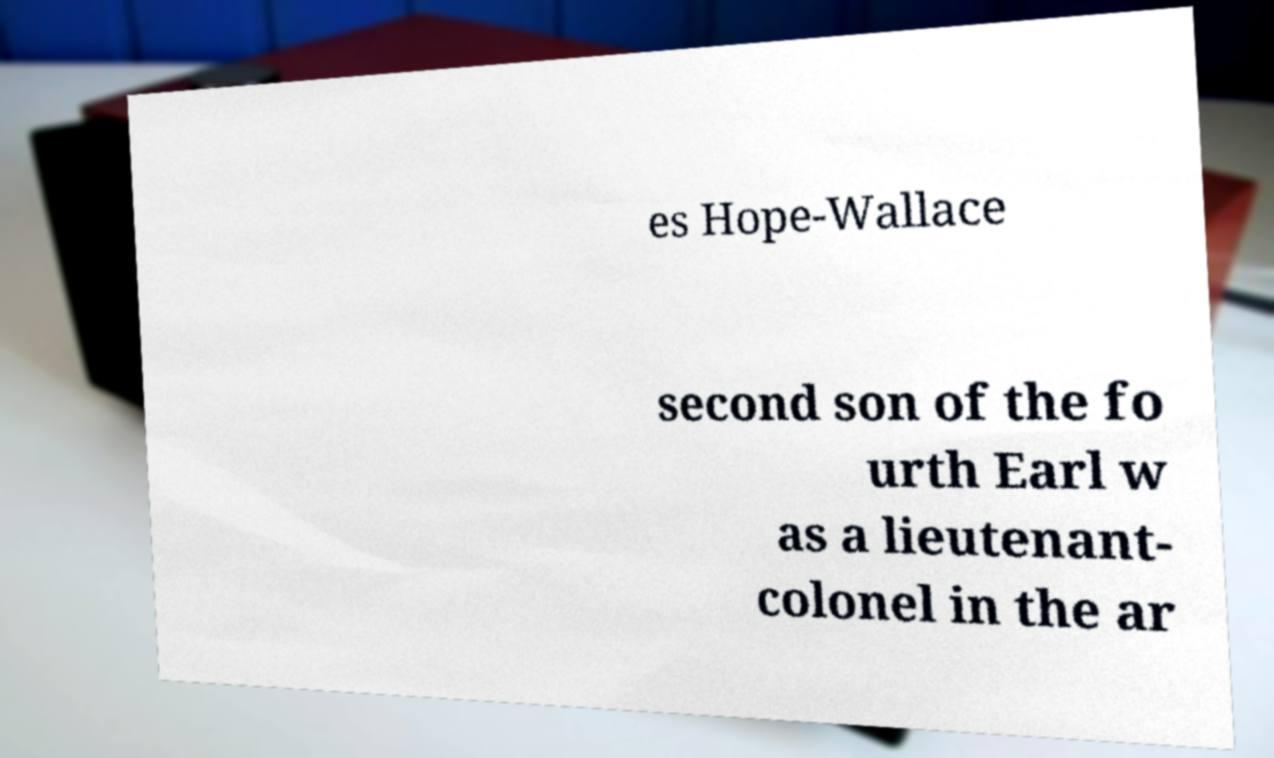For documentation purposes, I need the text within this image transcribed. Could you provide that? es Hope-Wallace second son of the fo urth Earl w as a lieutenant- colonel in the ar 